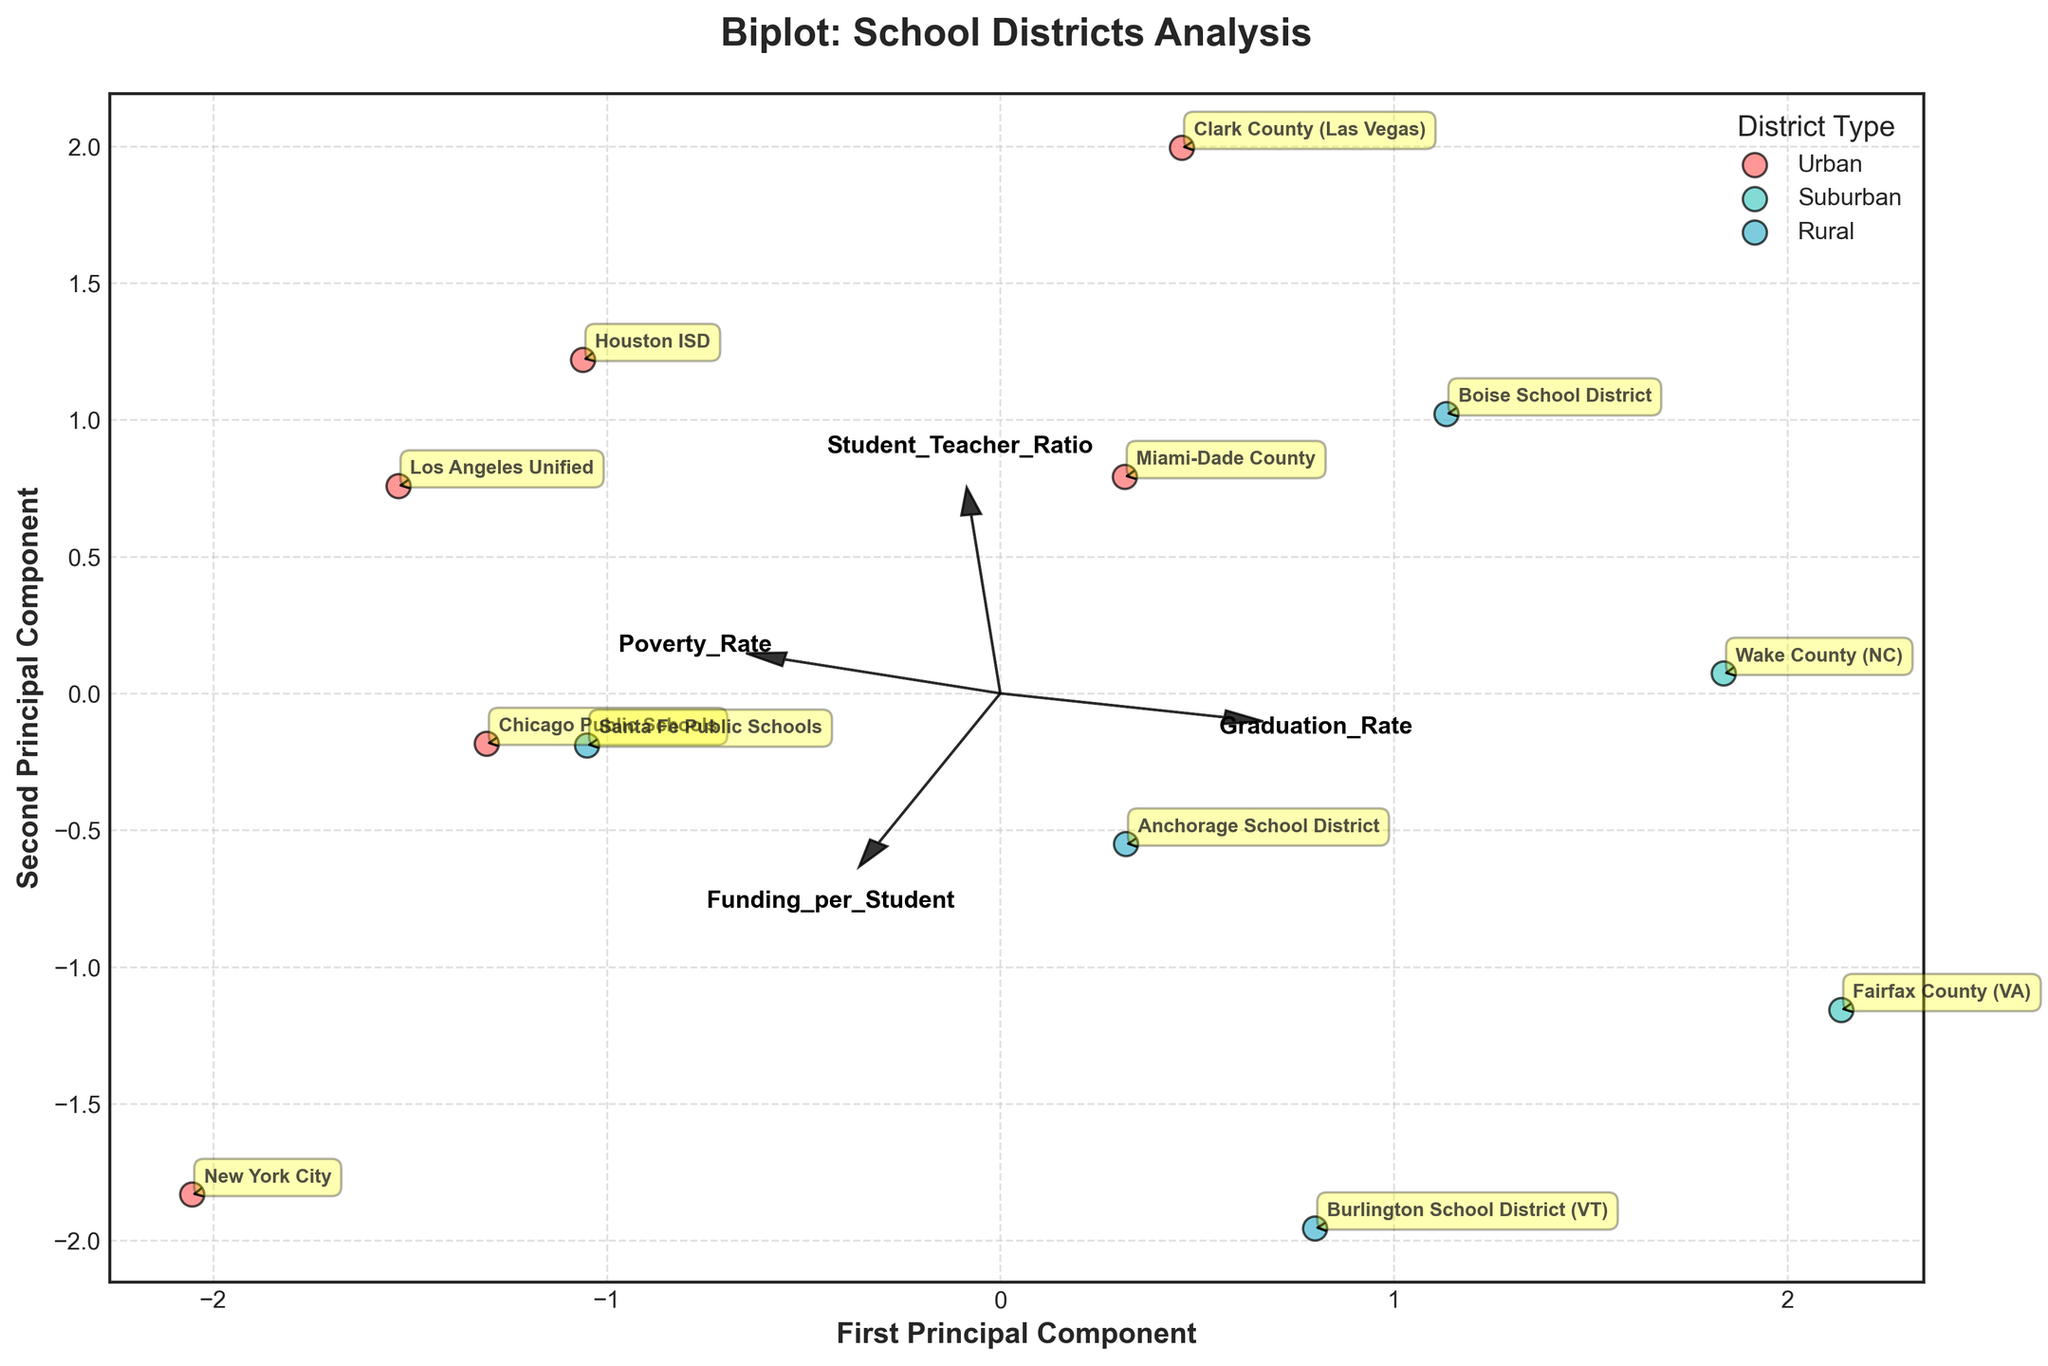How many school districts are analyzed in the biplot? The biplot visualizes data points representing each school district. By counting the number of points annotated with school district names, you can determine this number.
Answer: 12 What are the main components labeled on the axes of the biplot? The biplot typically shows the axes labeled with 'First Principal Component' and 'Second Principal Component' which represent the two main directions in which the data varies.
Answer: First Principal Component, Second Principal Component Which feature has the most influence in the direction of the first principal component? The feature whose vector is the longest and most aligned with the first principal component (horizontal axis) indicates the strongest influence. Observing the plot, we identify that "Funding_per_Student" is the most aligned.
Answer: Funding_per_Student Which district type has the highest concentration in the top-right quadrant? By examining the scatter plot and identifying the top-right quadrant, it can be seen that Urban districts have a higher number of points in this area.
Answer: Urban Which school district appears to have the highest Graduation Rate? The 'Graduation Rate' vector points in a direction where the respective district's data point aligns most closely at a larger distance from the origin. Observing the annotations, 'Fairfax County (VA)' aligns closest to this vector end.
Answer: Fairfax County (VA) Compare the position of 'Anchorage School District' and 'Santa Fe Public Schools' on the plot. Which one is closer to the origin? By examining their positions with respect to the origin (0,0), the 'Anchorage School District' is closer as it is less distant from the center compared to 'Santa Fe Public Schools'.
Answer: Anchorage School District Which feature appears to be less associated with the variations captured by the first two principal components? The feature whose vector length is shortest or stands out less prominently in either direction along the principal components suggests weaker association. 'Poverty_Rate' seems to have the shortest vector in this plot.
Answer: Poverty_Rate Does 'Student_Teacher_Ratio' positively or negatively correlate with 'Graduation_Rate'? By looking at the direction of their respective vectors, if they point in similar directions, they are positively correlated, and if they point in opposite directions, they are negatively correlated. Both vectors point relatively in opposite directions in the plot.
Answer: Negatively Which district type tends to have higher funding per student? Observing the biplot, 'Urban' districts are generally more aligned with the 'Funding_per_Student' vector, indicated by their closer positions to the vector end.
Answer: Urban 